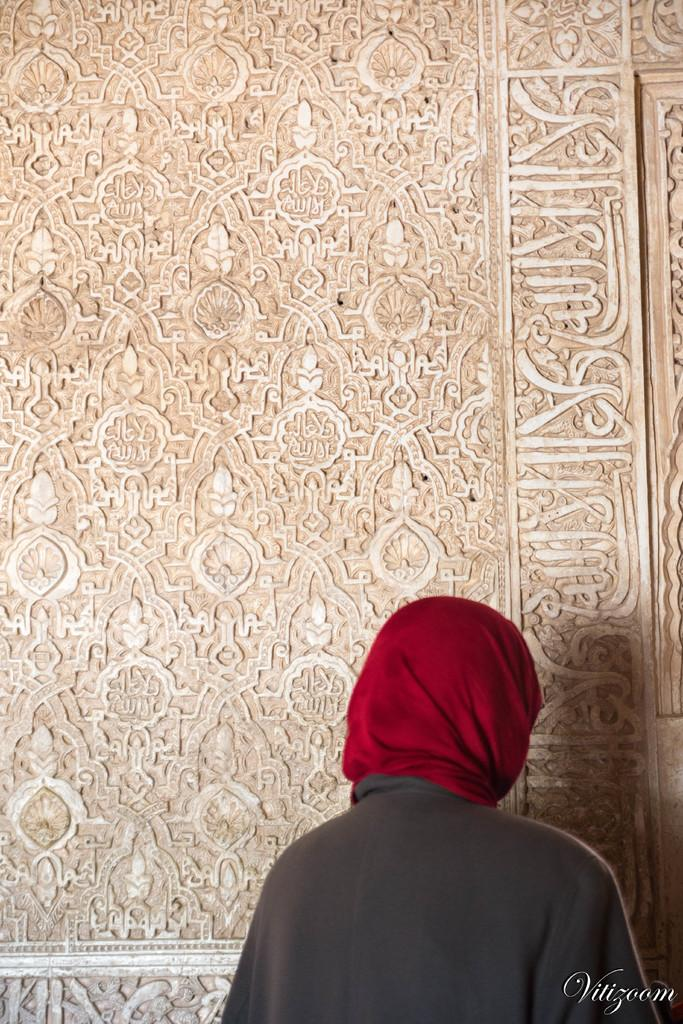Who is present at the bottom of the image? There is a lady at the bottom of the image. What else can be seen in the image besides the lady? There is some text in the image. What is visible in the background of the image? There is a wall with carvings in the background of the image. What type of egg is being used as a prop in the image? There is no egg present in the image. What kind of food is being prepared in the image? There is no food preparation visible in the image. 